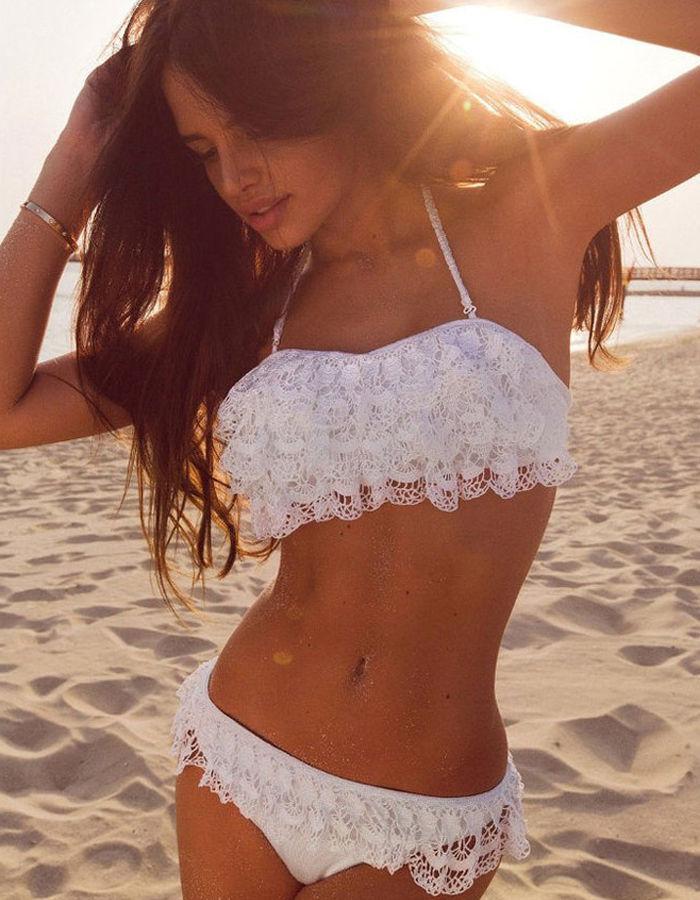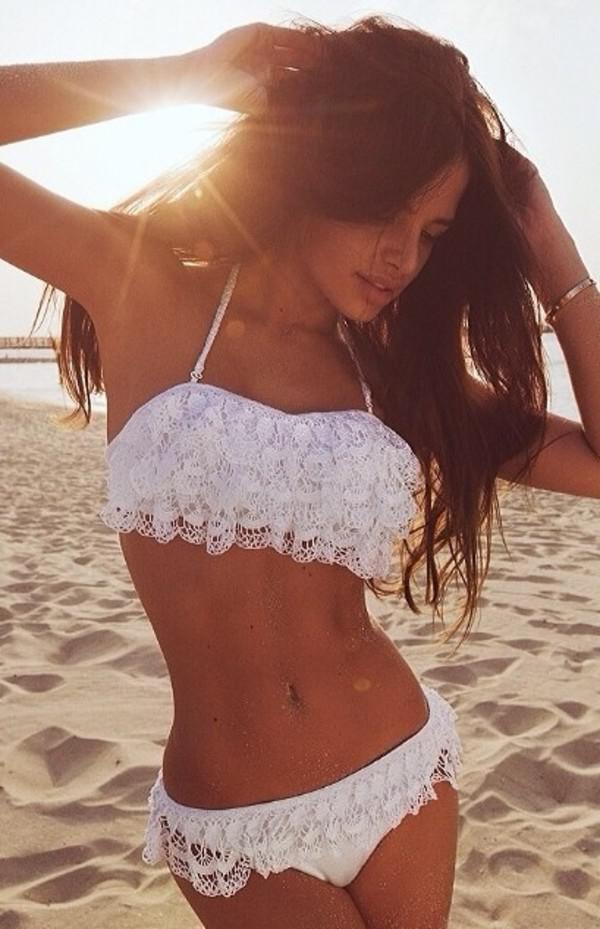The first image is the image on the left, the second image is the image on the right. For the images displayed, is the sentence "The swimsuit top in one image has a large ruffle that covers the bra and extends over the upper arms of the model." factually correct? Answer yes or no. No. 